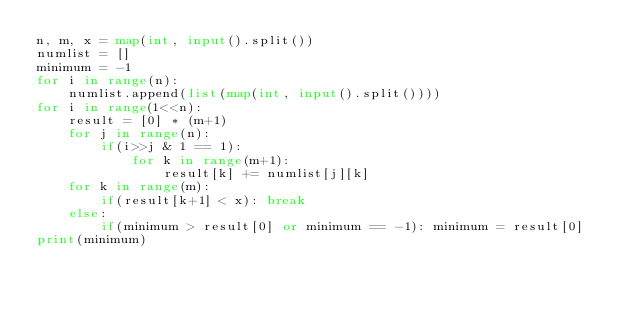Convert code to text. <code><loc_0><loc_0><loc_500><loc_500><_Python_>n, m, x = map(int, input().split())
numlist = []
minimum = -1
for i in range(n):
    numlist.append(list(map(int, input().split())))
for i in range(1<<n):
    result = [0] * (m+1)
    for j in range(n):
        if(i>>j & 1 == 1):
            for k in range(m+1):
                result[k] += numlist[j][k]
    for k in range(m):
        if(result[k+1] < x): break
    else:
        if(minimum > result[0] or minimum == -1): minimum = result[0]
print(minimum)</code> 